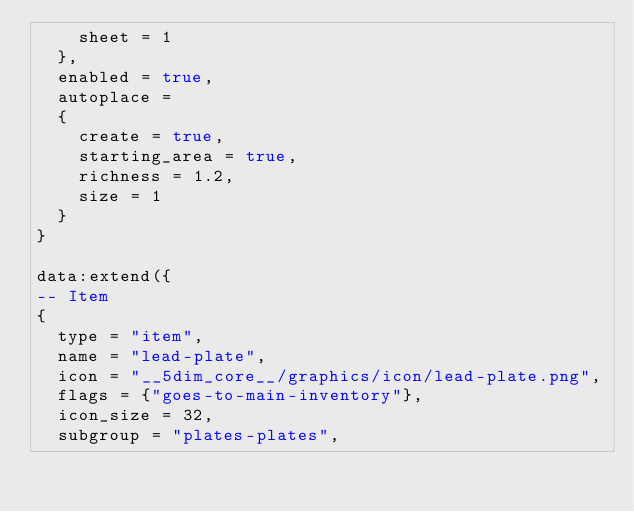<code> <loc_0><loc_0><loc_500><loc_500><_Lua_>    sheet = 1
  },
  enabled = true,
  autoplace =
  {
    create = true,
    starting_area = true,
    richness = 1.2,
    size = 1
  }
}

data:extend({
-- Item
{
  type = "item",
  name = "lead-plate",
  icon = "__5dim_core__/graphics/icon/lead-plate.png",
  flags = {"goes-to-main-inventory"},
  icon_size = 32,
  subgroup = "plates-plates",</code> 